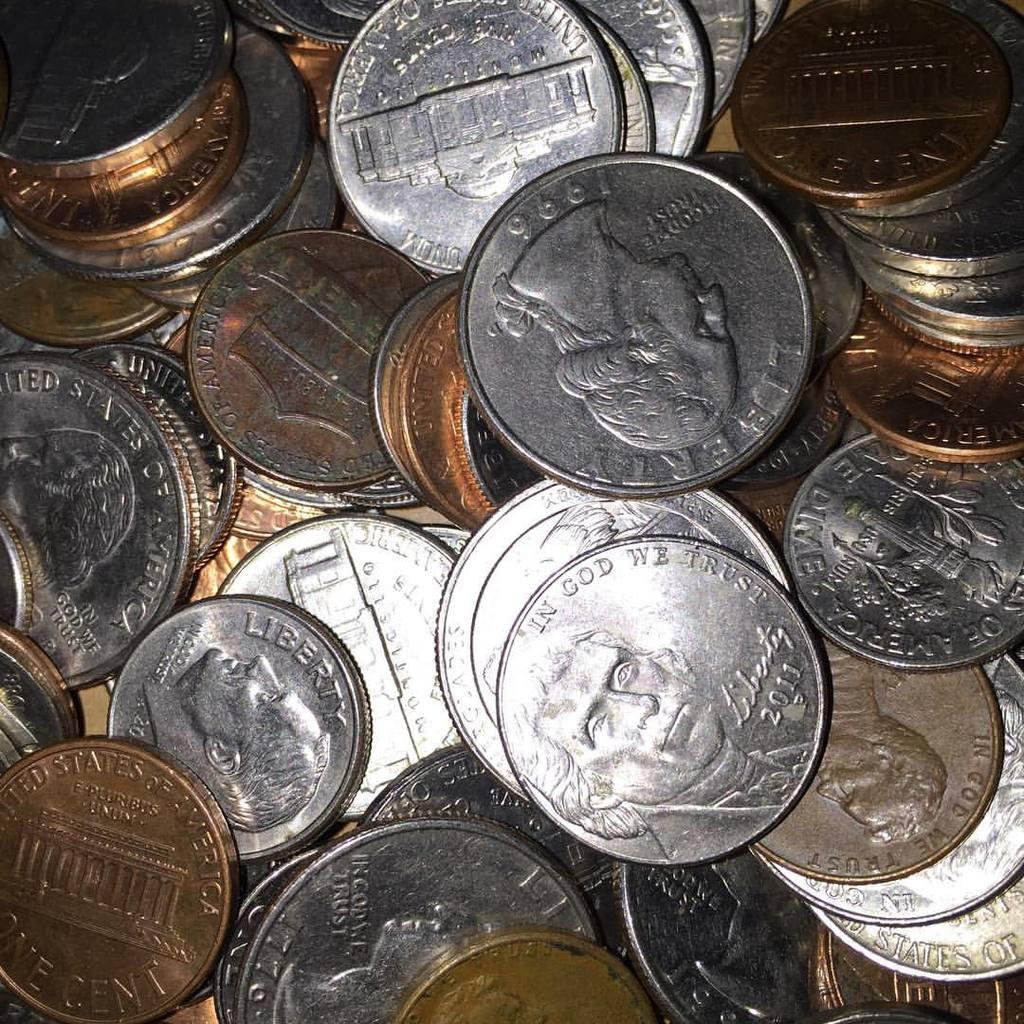<image>
Render a clear and concise summary of the photo. Man coins on top of a table and silver coin on top that says In God We Trust. 